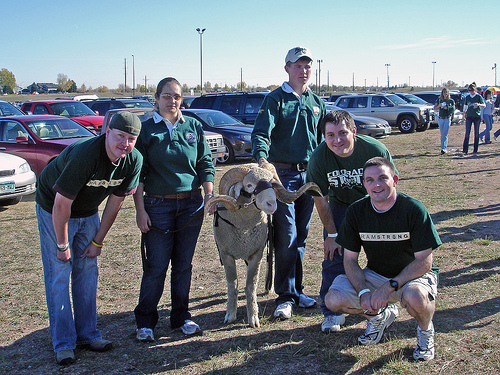<image>
Can you confirm if the sheep is on the ground? Yes. Looking at the image, I can see the sheep is positioned on top of the ground, with the ground providing support. Is the shirt on the person? No. The shirt is not positioned on the person. They may be near each other, but the shirt is not supported by or resting on top of the person. Where is the sky in relation to the car? Is it behind the car? Yes. From this viewpoint, the sky is positioned behind the car, with the car partially or fully occluding the sky. Is the sheep to the right of the boy? Yes. From this viewpoint, the sheep is positioned to the right side relative to the boy. 